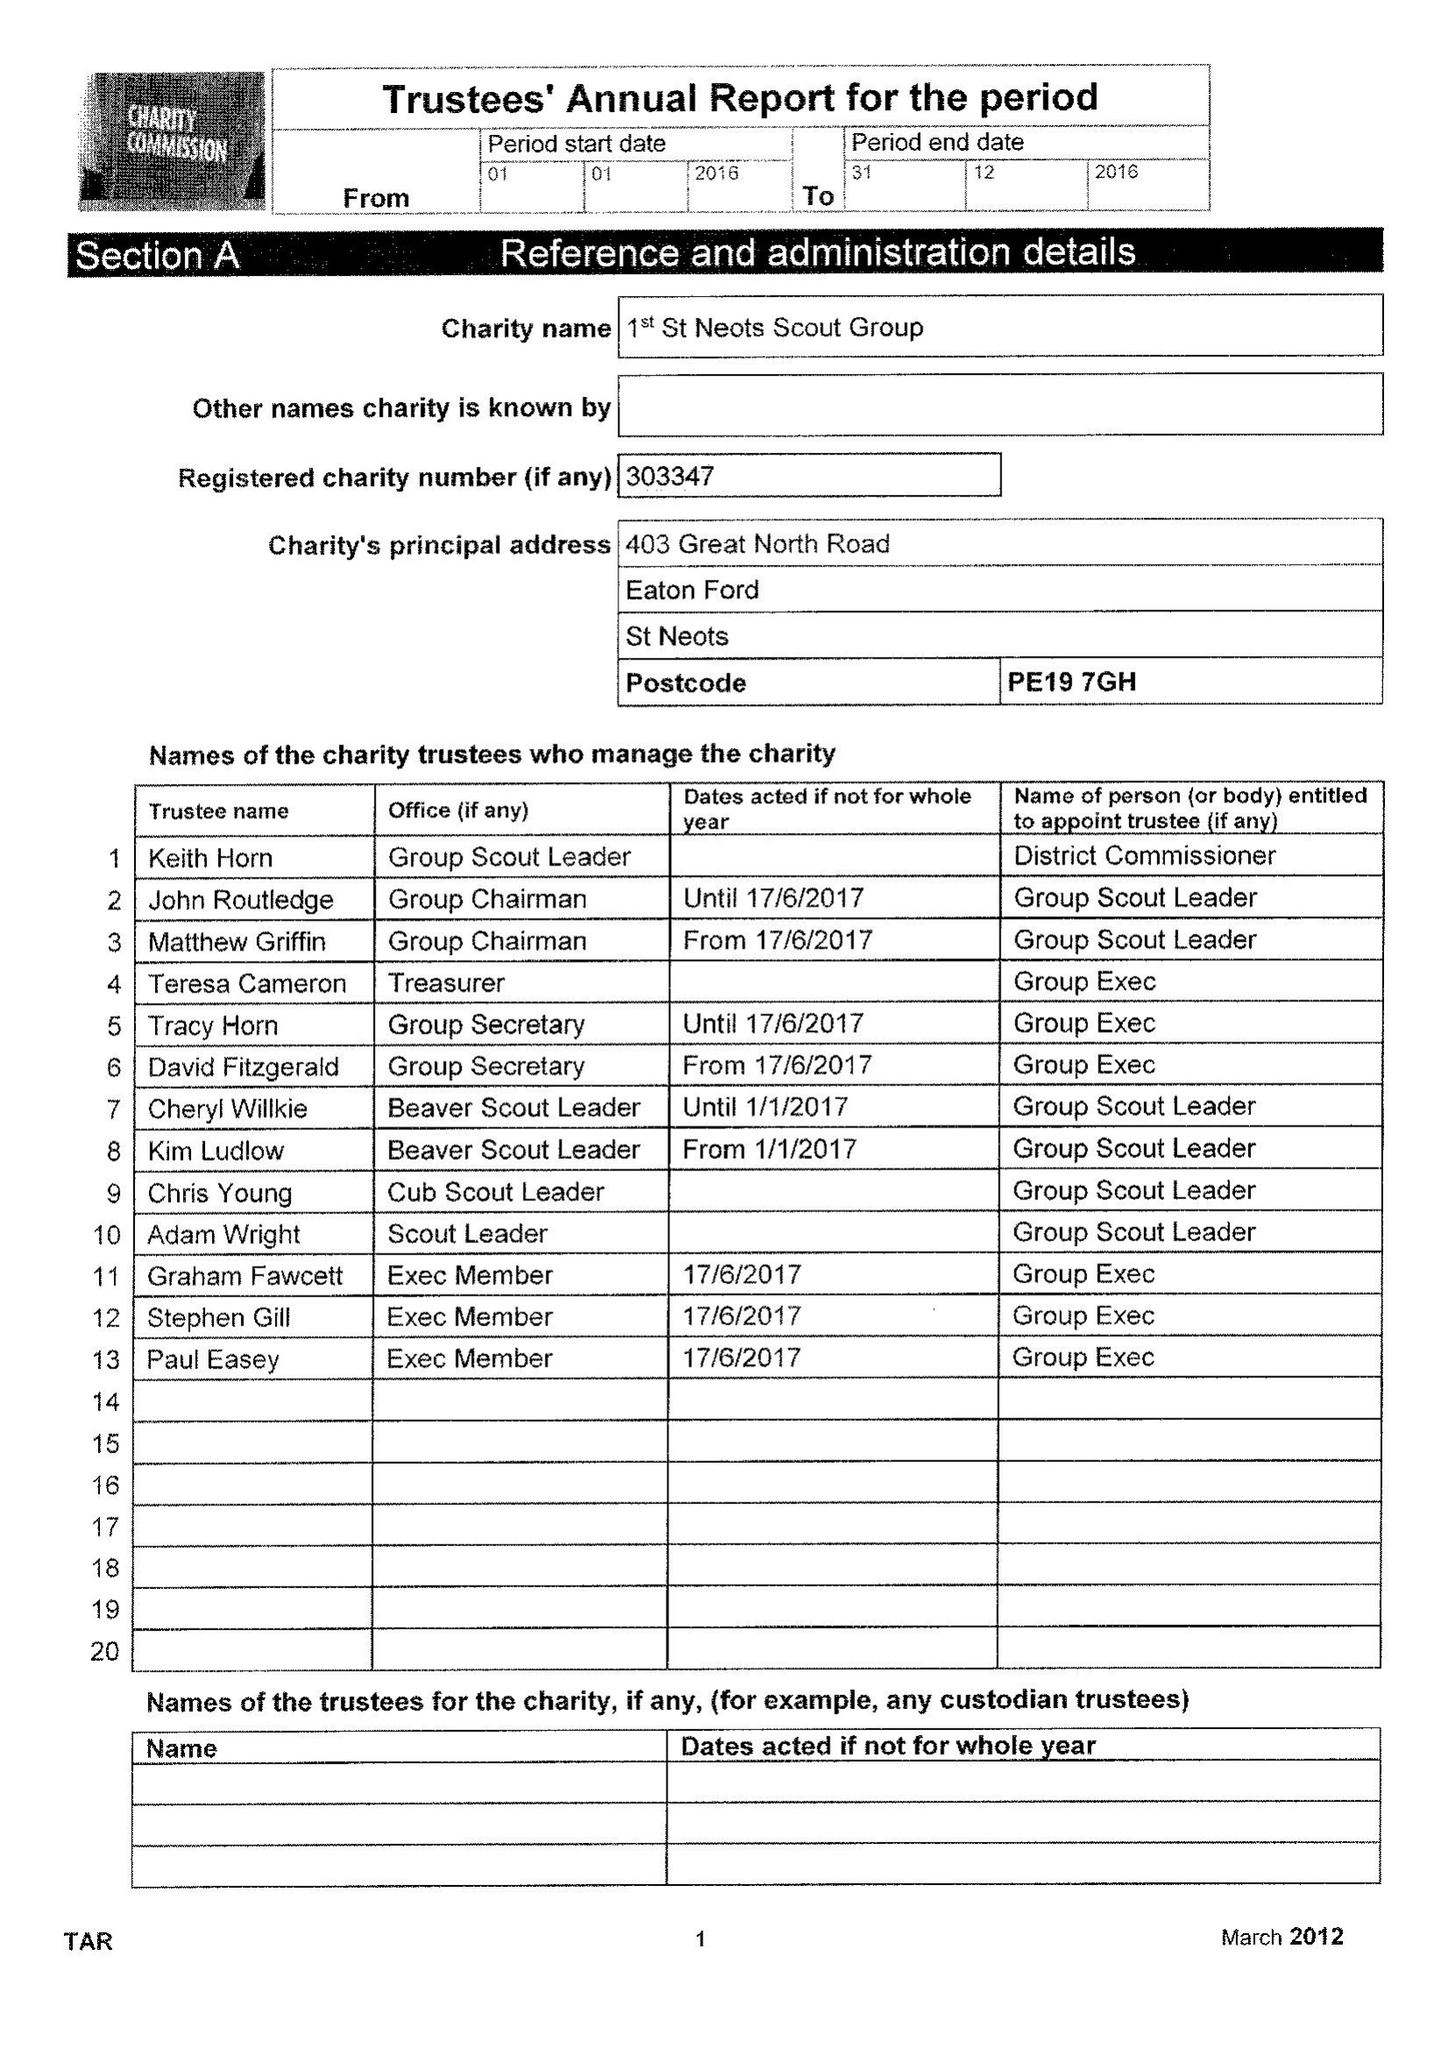What is the value for the charity_name?
Answer the question using a single word or phrase. 1st St Neots Scout Group 